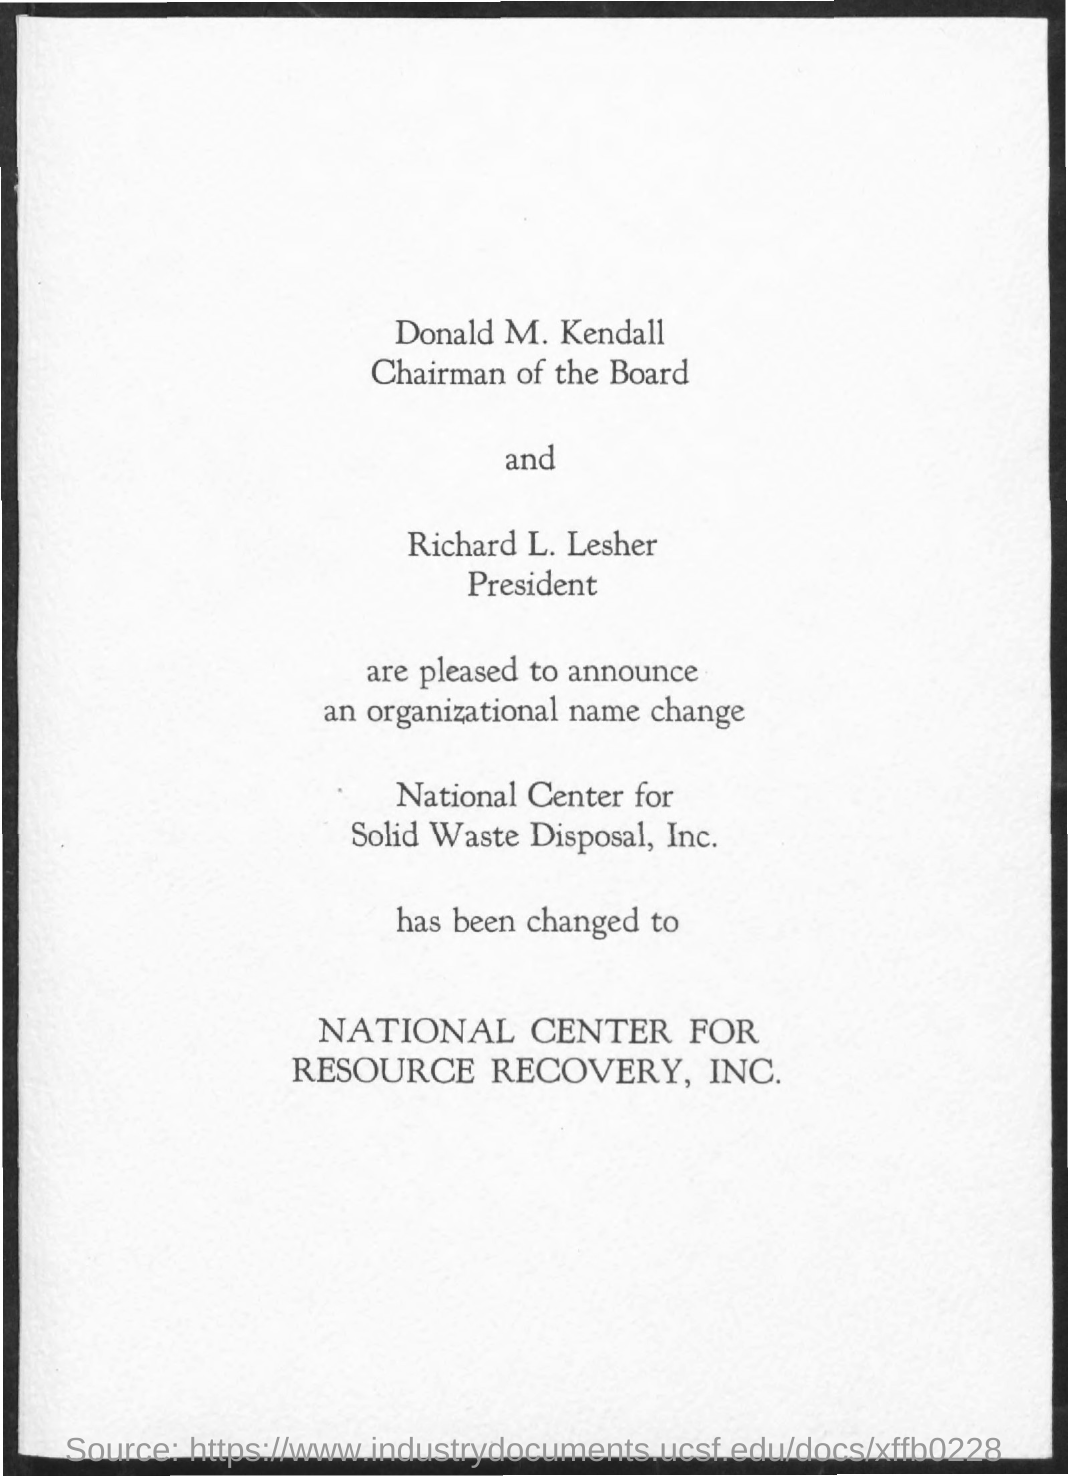Highlight a few significant elements in this photo. The name of National Center for Solid Waste Disposal, Inc. has been changed to National Center for Resource Recovery, Inc. It is confirmed that Donald M. Kendall is the chairman of the board. Richard L. Lesher holds the designation of President. 